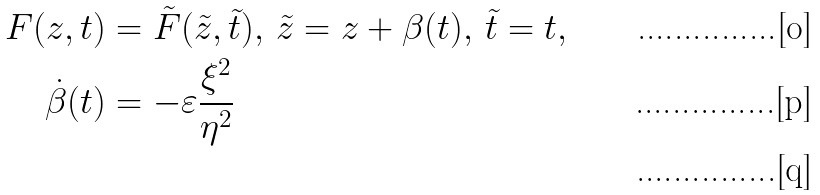Convert formula to latex. <formula><loc_0><loc_0><loc_500><loc_500>F ( z , t ) & = \tilde { F } ( \tilde { z } , \tilde { t } ) , \, \tilde { z } = z + \beta ( t ) , \, \tilde { t } = t , \\ \dot { \beta } ( t ) & = - \varepsilon \frac { \xi ^ { 2 } } { \eta ^ { 2 } } \\</formula> 